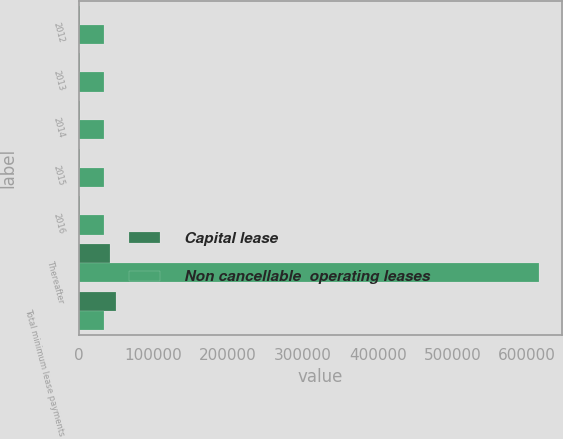Convert chart. <chart><loc_0><loc_0><loc_500><loc_500><stacked_bar_chart><ecel><fcel>2012<fcel>2013<fcel>2014<fcel>2015<fcel>2016<fcel>Thereafter<fcel>Total minimum lease payments<nl><fcel>Capital lease<fcel>1555<fcel>1555<fcel>1555<fcel>1592<fcel>1707<fcel>42351<fcel>50315<nl><fcel>Non cancellable  operating leases<fcel>33429<fcel>33429<fcel>33429<fcel>33429<fcel>33533<fcel>615450<fcel>33429<nl></chart> 